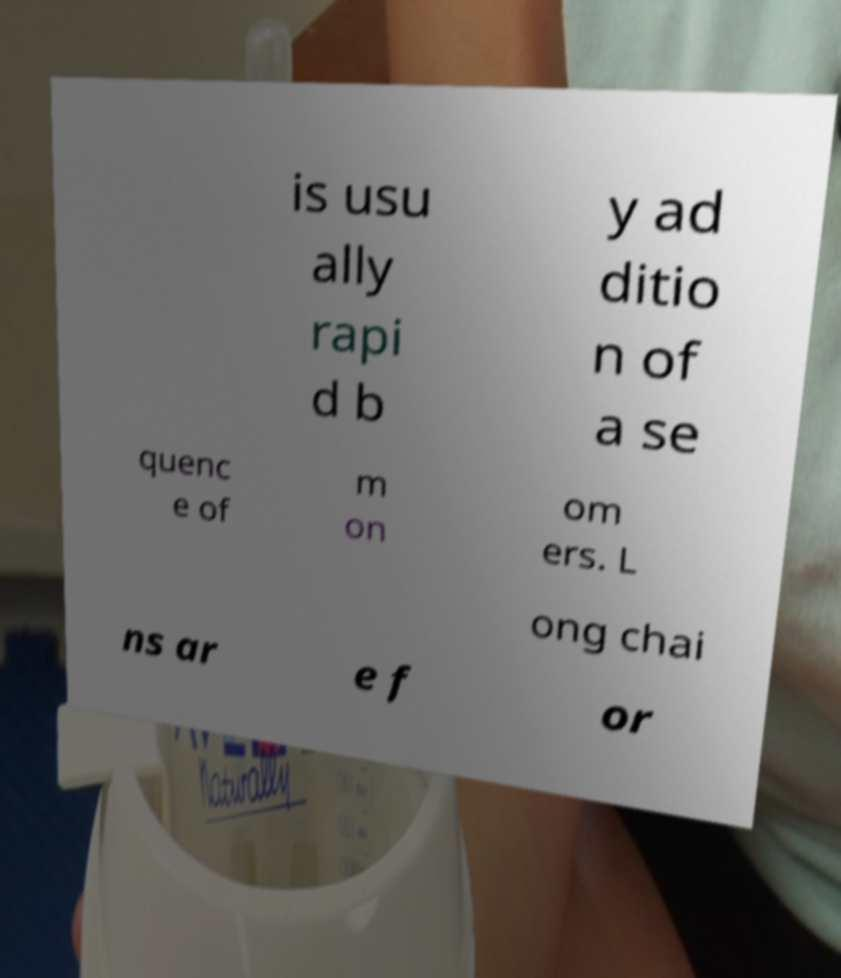For documentation purposes, I need the text within this image transcribed. Could you provide that? is usu ally rapi d b y ad ditio n of a se quenc e of m on om ers. L ong chai ns ar e f or 